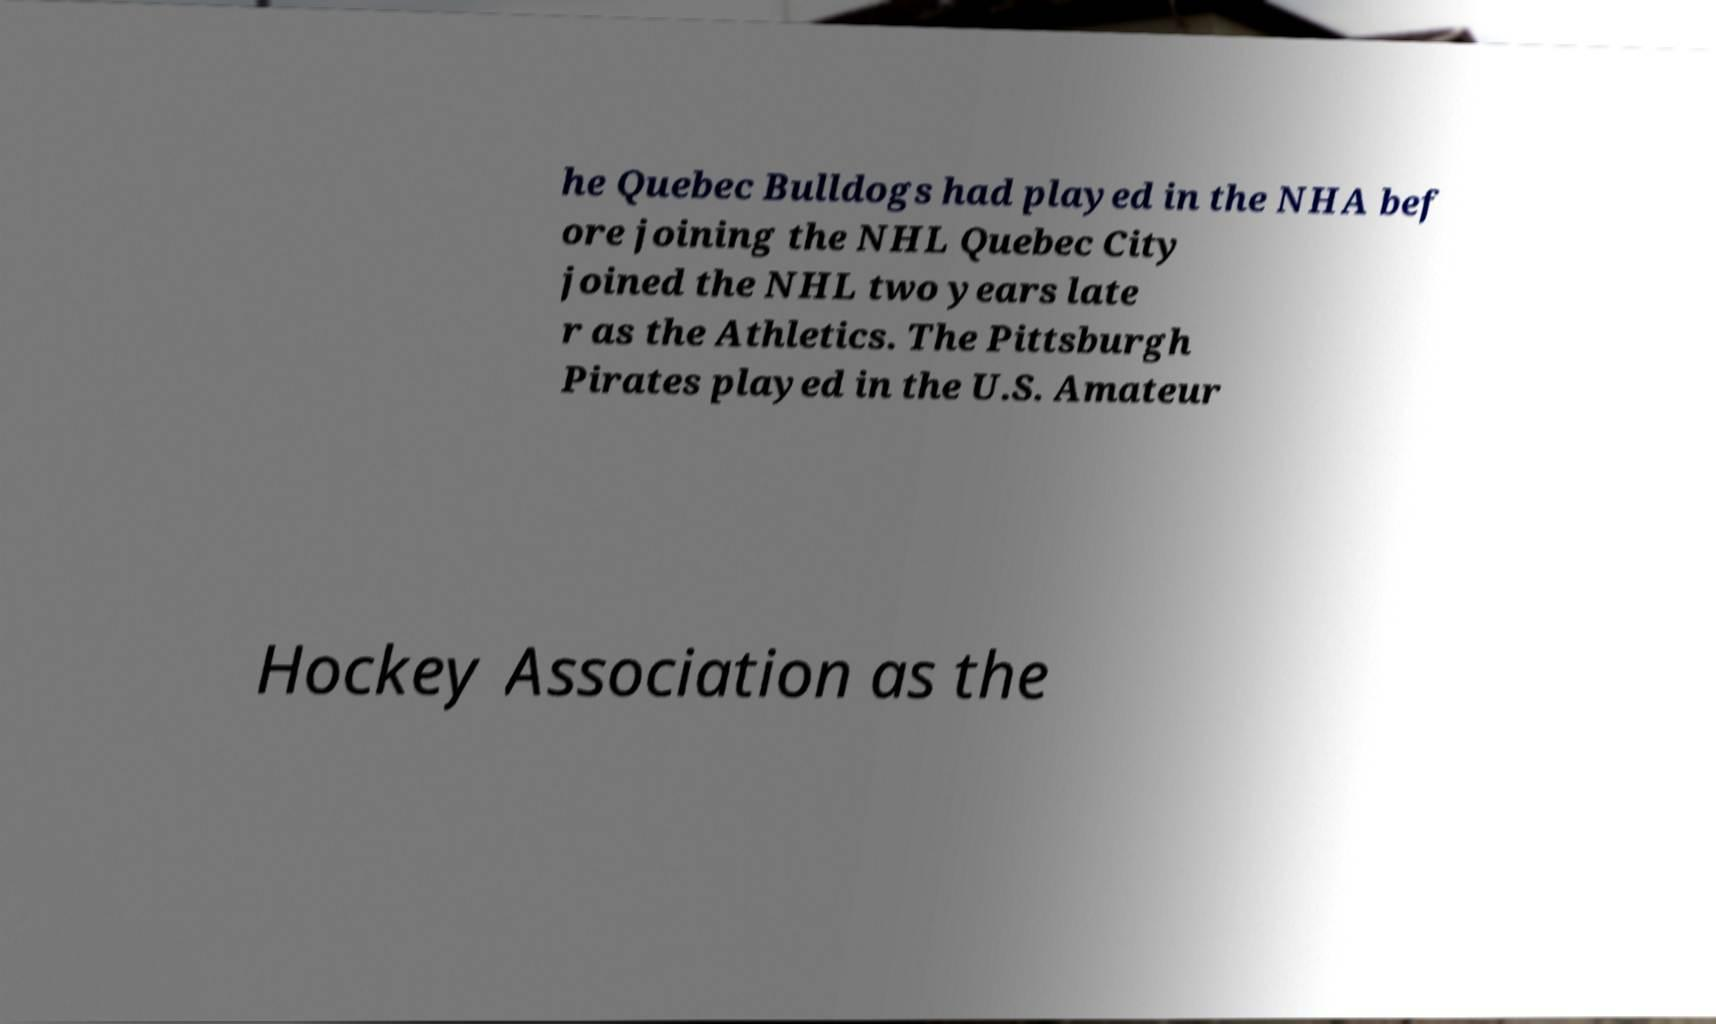Can you read and provide the text displayed in the image?This photo seems to have some interesting text. Can you extract and type it out for me? he Quebec Bulldogs had played in the NHA bef ore joining the NHL Quebec City joined the NHL two years late r as the Athletics. The Pittsburgh Pirates played in the U.S. Amateur Hockey Association as the 